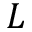Convert formula to latex. <formula><loc_0><loc_0><loc_500><loc_500>L</formula> 